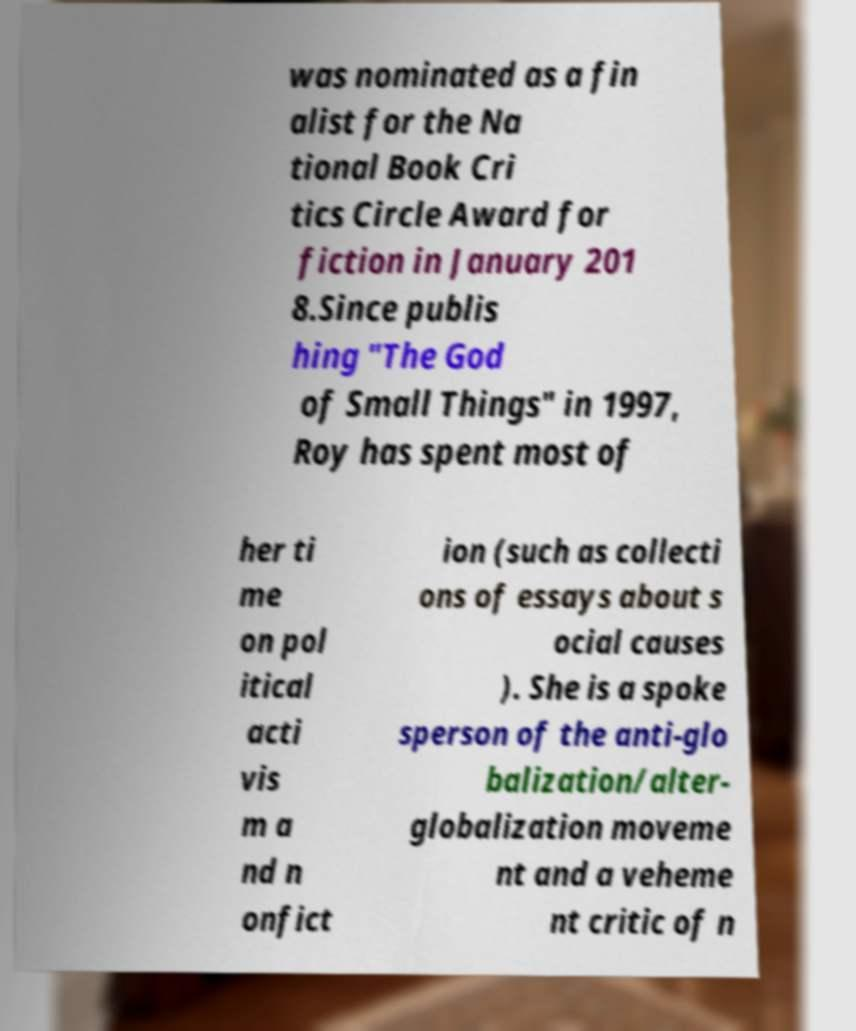Could you assist in decoding the text presented in this image and type it out clearly? was nominated as a fin alist for the Na tional Book Cri tics Circle Award for fiction in January 201 8.Since publis hing "The God of Small Things" in 1997, Roy has spent most of her ti me on pol itical acti vis m a nd n onfict ion (such as collecti ons of essays about s ocial causes ). She is a spoke sperson of the anti-glo balization/alter- globalization moveme nt and a veheme nt critic of n 